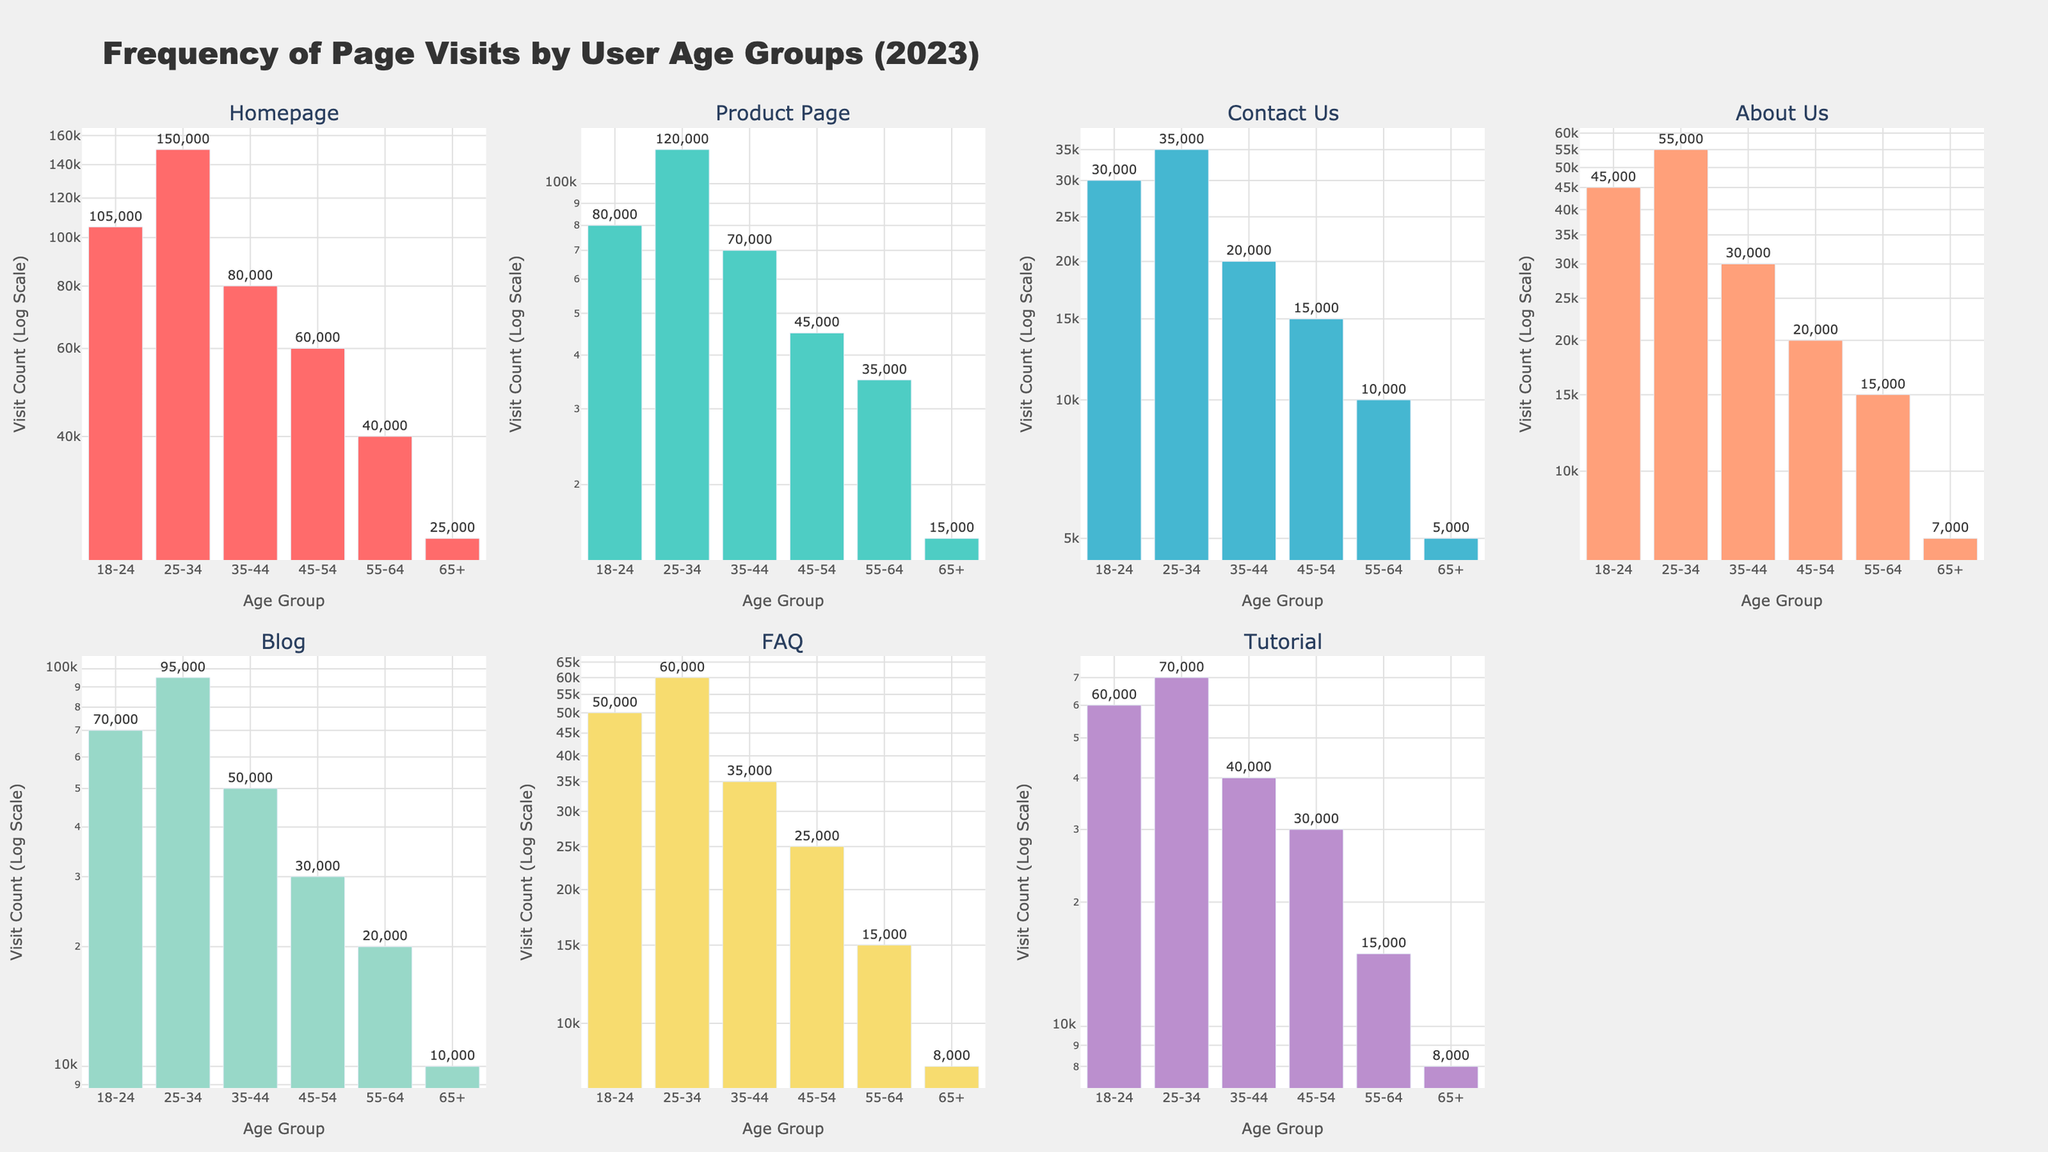How is the title of the figure phrased? The title is prominently displayed at the top center of the figure and reads as "Frequency of Page Visits by User Age Groups (2023)."
Answer: Frequency of Page Visits by User Age Groups (2023) Which age group has the highest number of visits to the Blog page? By examining the subplot for the Blog page, the tallest bar corresponds to the age group 25-34.
Answer: 25-34 What is the difference in visit counts between the age groups 18-24 and 25-34 for the Tutorial page? From the subplot for the Tutorial page, the visit counts for 18-24 and 25-34 are 60,000 and 70,000 respectively. The difference is 70,000 - 60,000 = 10,000.
Answer: 10,000 Which age group visited the Homepage the least, and what is the visit count? In the Homepage subplot, the smallest bar corresponds to the age group 65+ with a visit count of 25,000.
Answer: 65+, 25,000 For the Product Page, what is the average number of visits across all age groups? Summing the Product Page visits across age groups: 80,000 (18-24), 120,000 (25-34), 70,000 (35-44), 45,000 (45-54), 35,000 (55-64), and 15,000 (65+) equals 365,000. Dividing by 6 age groups, the average is 365,000 / 6 = 60,833.33.
Answer: 60,833.33 Which age group has the highest number of visits to the Contact Us page, and how many visits did they make? In the Contact Us subplot, the tallest bar corresponds to the age group 25-34 with 35,000 visits.
Answer: 25-34, 35,000 How does the visit count for the About Us page compare between the age groups 35-44 and 55-64? For the About Us page, the bars show 35,000 for the age group 35-44 and 15,000 for the age group 55-64. Therefore, the age group 35-44 has 20,000 more visits (35,000 - 15,000).
Answer: 20,000 more visits in 35-44 What's the total visit count for the FAQ page across all age groups? Summing the FAQ visits for each age group: 50,000 (18-24), 60,000 (25-34), 35,000 (35-44), 25,000 (45-54), 15,000 (55-64), and 8,000 (65+) equals 193,000 visits in total.
Answer: 193,000 Compare the log scale y-axes: which two subplots have the closest maximum values, and what are those values? Comparing the maximum values on the log scale y-axes, the Homepage and Product Page subplots both reach around 150,000 which makes them the closest maximum values.
Answer: Homepage and Product Page, approximately 150,000 each 